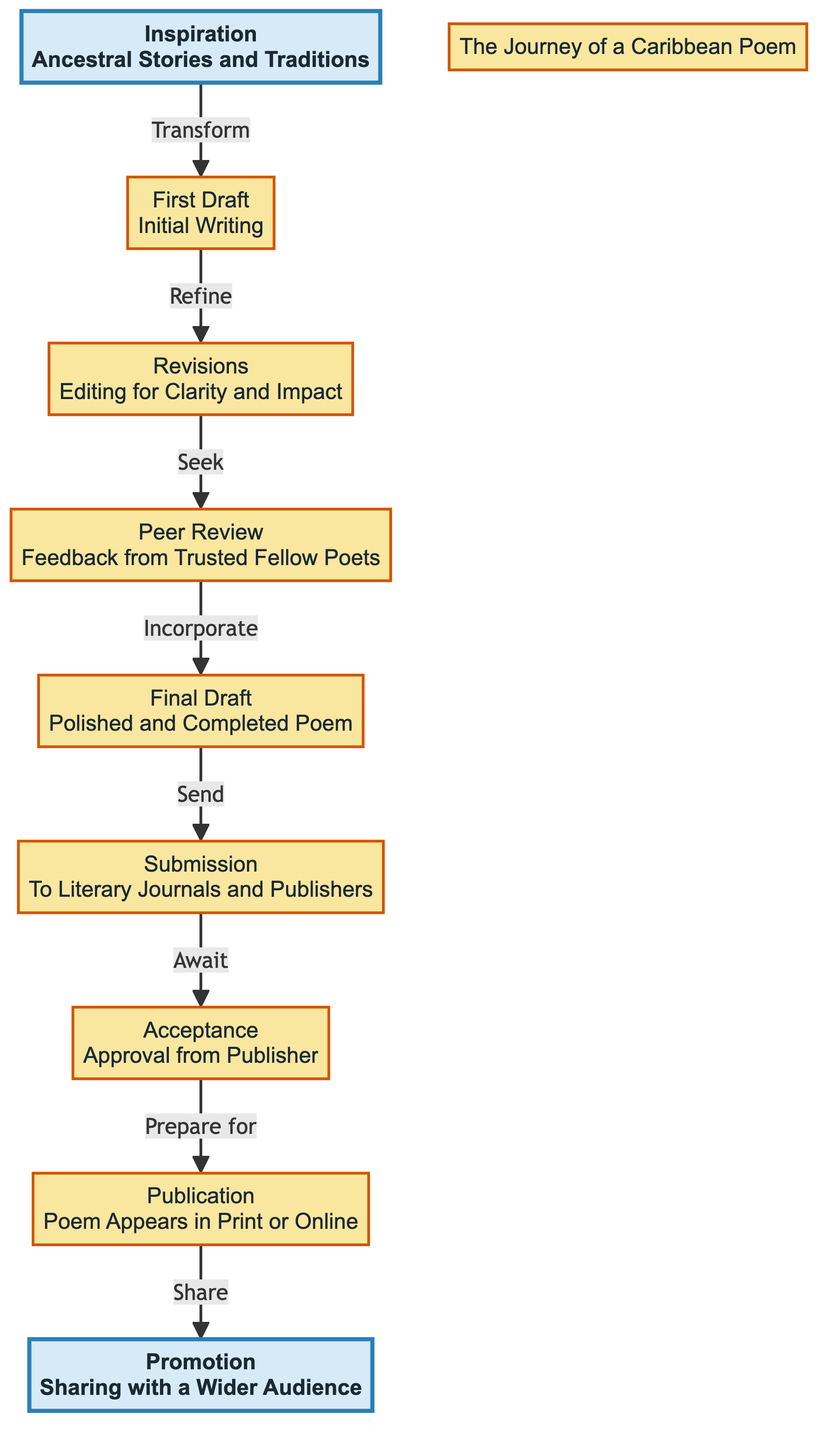What is the first step in the journey of a poem? The diagram indicates that the process begins with "Inspiration," which is derived from ancestral stories and traditions. This is the initial stage.
Answer: Inspiration How many main steps are there from inspiration to promotion? By counting the distinct elements in the flowchart, there are a total of nine steps represented.
Answer: Nine What comes after "Peer Review"? According to the diagram, the next step following "Peer Review" is "Final Draft." This indicates that feedback is incorporated into the poem to create a polished version.
Answer: Final Draft Which step involves feedback from fellow poets? The diagram clearly shows that the "Peer Review" step is the one where feedback is sought from trusted fellow poets, indicating collaboration and constructive criticism.
Answer: Peer Review What is the final outcome of the publication journey? The last element in the flowchart is "Promotion," which highlights that the final outcome involves sharing the poem with a wider audience after it has been published.
Answer: Promotion Which step requires sending the poem to literary journals? The diagram specifies that "Submission" is the step where the poet sends the poem to literary journals and publishers, serving as a critical moment before acceptance.
Answer: Submission What is indicated as the role of "Acceptance" in the process? The diagram indicates that "Acceptance" serves as the approval stage from the publisher, allowing the poet to proceed toward publication after submission.
Answer: Approval from Publisher What does the "Final Draft" step focus on? The "Final Draft" step, as described in the diagram, is centered on making final adjustments and incorporating feedback, resulting in a polished and completed poem.
Answer: Polished and Completed Poem How does "Inspiration" transform into the first draft? The flow indicates that "Inspiration" transforms into "First Draft" through the creative act of initial writing, where the poet starts to shape their thoughts into verse.
Answer: Initial Writing 